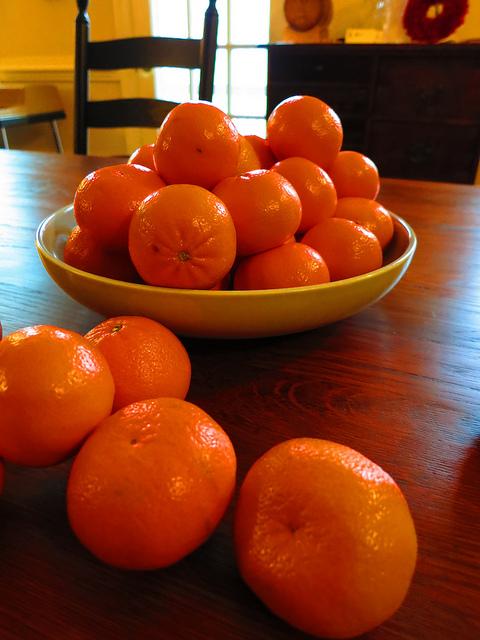What is the color of bowl were fruits are?
Be succinct. Yellow. How many oranges are there?
Give a very brief answer. 17. What is making this room so bright?
Keep it brief. Sun. What type of fruit is this?
Short answer required. Orange. What fruit is this?
Be succinct. Orange. 